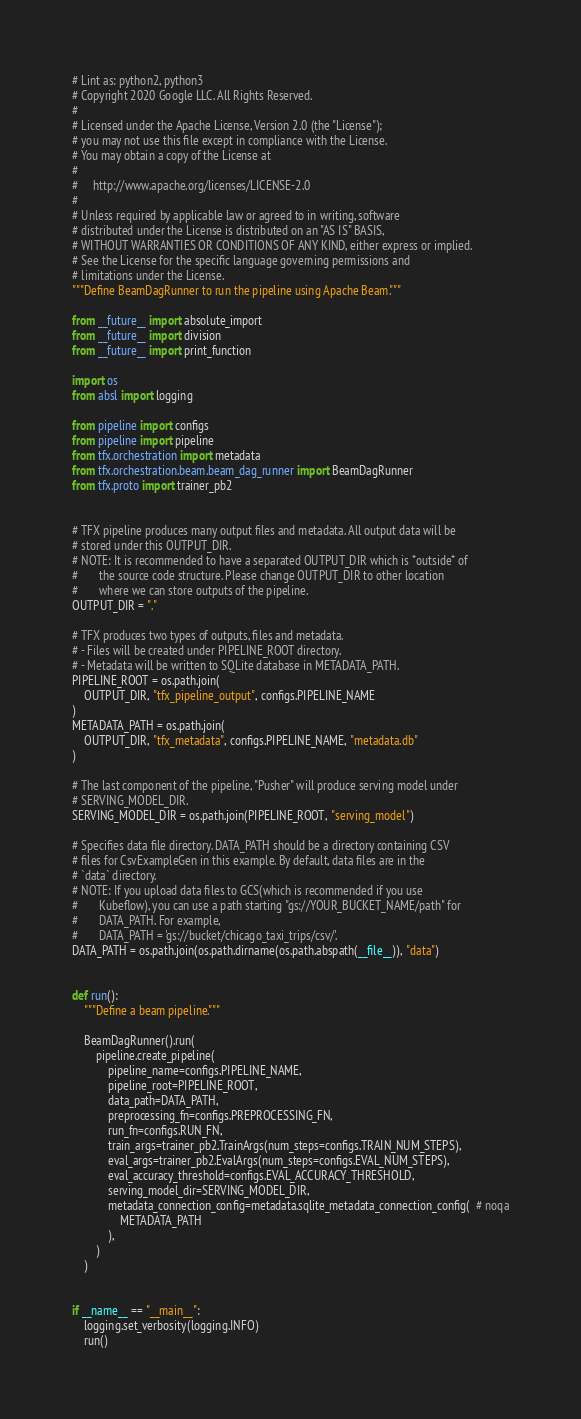<code> <loc_0><loc_0><loc_500><loc_500><_Python_># Lint as: python2, python3
# Copyright 2020 Google LLC. All Rights Reserved.
#
# Licensed under the Apache License, Version 2.0 (the "License");
# you may not use this file except in compliance with the License.
# You may obtain a copy of the License at
#
#     http://www.apache.org/licenses/LICENSE-2.0
#
# Unless required by applicable law or agreed to in writing, software
# distributed under the License is distributed on an "AS IS" BASIS,
# WITHOUT WARRANTIES OR CONDITIONS OF ANY KIND, either express or implied.
# See the License for the specific language governing permissions and
# limitations under the License.
"""Define BeamDagRunner to run the pipeline using Apache Beam."""

from __future__ import absolute_import
from __future__ import division
from __future__ import print_function

import os
from absl import logging

from pipeline import configs
from pipeline import pipeline
from tfx.orchestration import metadata
from tfx.orchestration.beam.beam_dag_runner import BeamDagRunner
from tfx.proto import trainer_pb2


# TFX pipeline produces many output files and metadata. All output data will be
# stored under this OUTPUT_DIR.
# NOTE: It is recommended to have a separated OUTPUT_DIR which is *outside* of
#       the source code structure. Please change OUTPUT_DIR to other location
#       where we can store outputs of the pipeline.
OUTPUT_DIR = "."

# TFX produces two types of outputs, files and metadata.
# - Files will be created under PIPELINE_ROOT directory.
# - Metadata will be written to SQLite database in METADATA_PATH.
PIPELINE_ROOT = os.path.join(
    OUTPUT_DIR, "tfx_pipeline_output", configs.PIPELINE_NAME
)
METADATA_PATH = os.path.join(
    OUTPUT_DIR, "tfx_metadata", configs.PIPELINE_NAME, "metadata.db"
)

# The last component of the pipeline, "Pusher" will produce serving model under
# SERVING_MODEL_DIR.
SERVING_MODEL_DIR = os.path.join(PIPELINE_ROOT, "serving_model")

# Specifies data file directory. DATA_PATH should be a directory containing CSV
# files for CsvExampleGen in this example. By default, data files are in the
# `data` directory.
# NOTE: If you upload data files to GCS(which is recommended if you use
#       Kubeflow), you can use a path starting "gs://YOUR_BUCKET_NAME/path" for
#       DATA_PATH. For example,
#       DATA_PATH = 'gs://bucket/chicago_taxi_trips/csv/'.
DATA_PATH = os.path.join(os.path.dirname(os.path.abspath(__file__)), "data")


def run():
    """Define a beam pipeline."""

    BeamDagRunner().run(
        pipeline.create_pipeline(
            pipeline_name=configs.PIPELINE_NAME,
            pipeline_root=PIPELINE_ROOT,
            data_path=DATA_PATH,
            preprocessing_fn=configs.PREPROCESSING_FN,
            run_fn=configs.RUN_FN,
            train_args=trainer_pb2.TrainArgs(num_steps=configs.TRAIN_NUM_STEPS),
            eval_args=trainer_pb2.EvalArgs(num_steps=configs.EVAL_NUM_STEPS),
            eval_accuracy_threshold=configs.EVAL_ACCURACY_THRESHOLD,
            serving_model_dir=SERVING_MODEL_DIR,
            metadata_connection_config=metadata.sqlite_metadata_connection_config(  # noqa
                METADATA_PATH
            ),
        )
    )


if __name__ == "__main__":
    logging.set_verbosity(logging.INFO)
    run()
</code> 